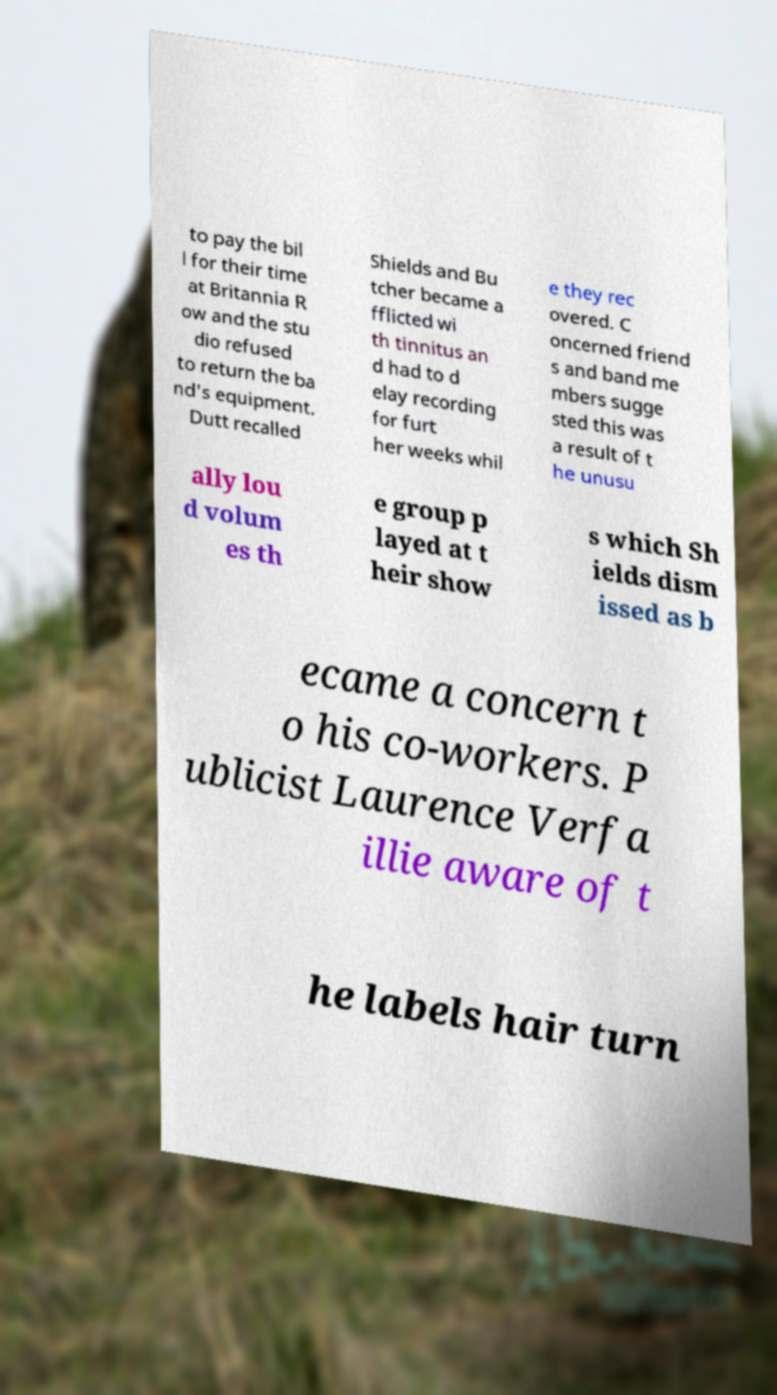There's text embedded in this image that I need extracted. Can you transcribe it verbatim? to pay the bil l for their time at Britannia R ow and the stu dio refused to return the ba nd's equipment. Dutt recalled Shields and Bu tcher became a fflicted wi th tinnitus an d had to d elay recording for furt her weeks whil e they rec overed. C oncerned friend s and band me mbers sugge sted this was a result of t he unusu ally lou d volum es th e group p layed at t heir show s which Sh ields dism issed as b ecame a concern t o his co-workers. P ublicist Laurence Verfa illie aware of t he labels hair turn 